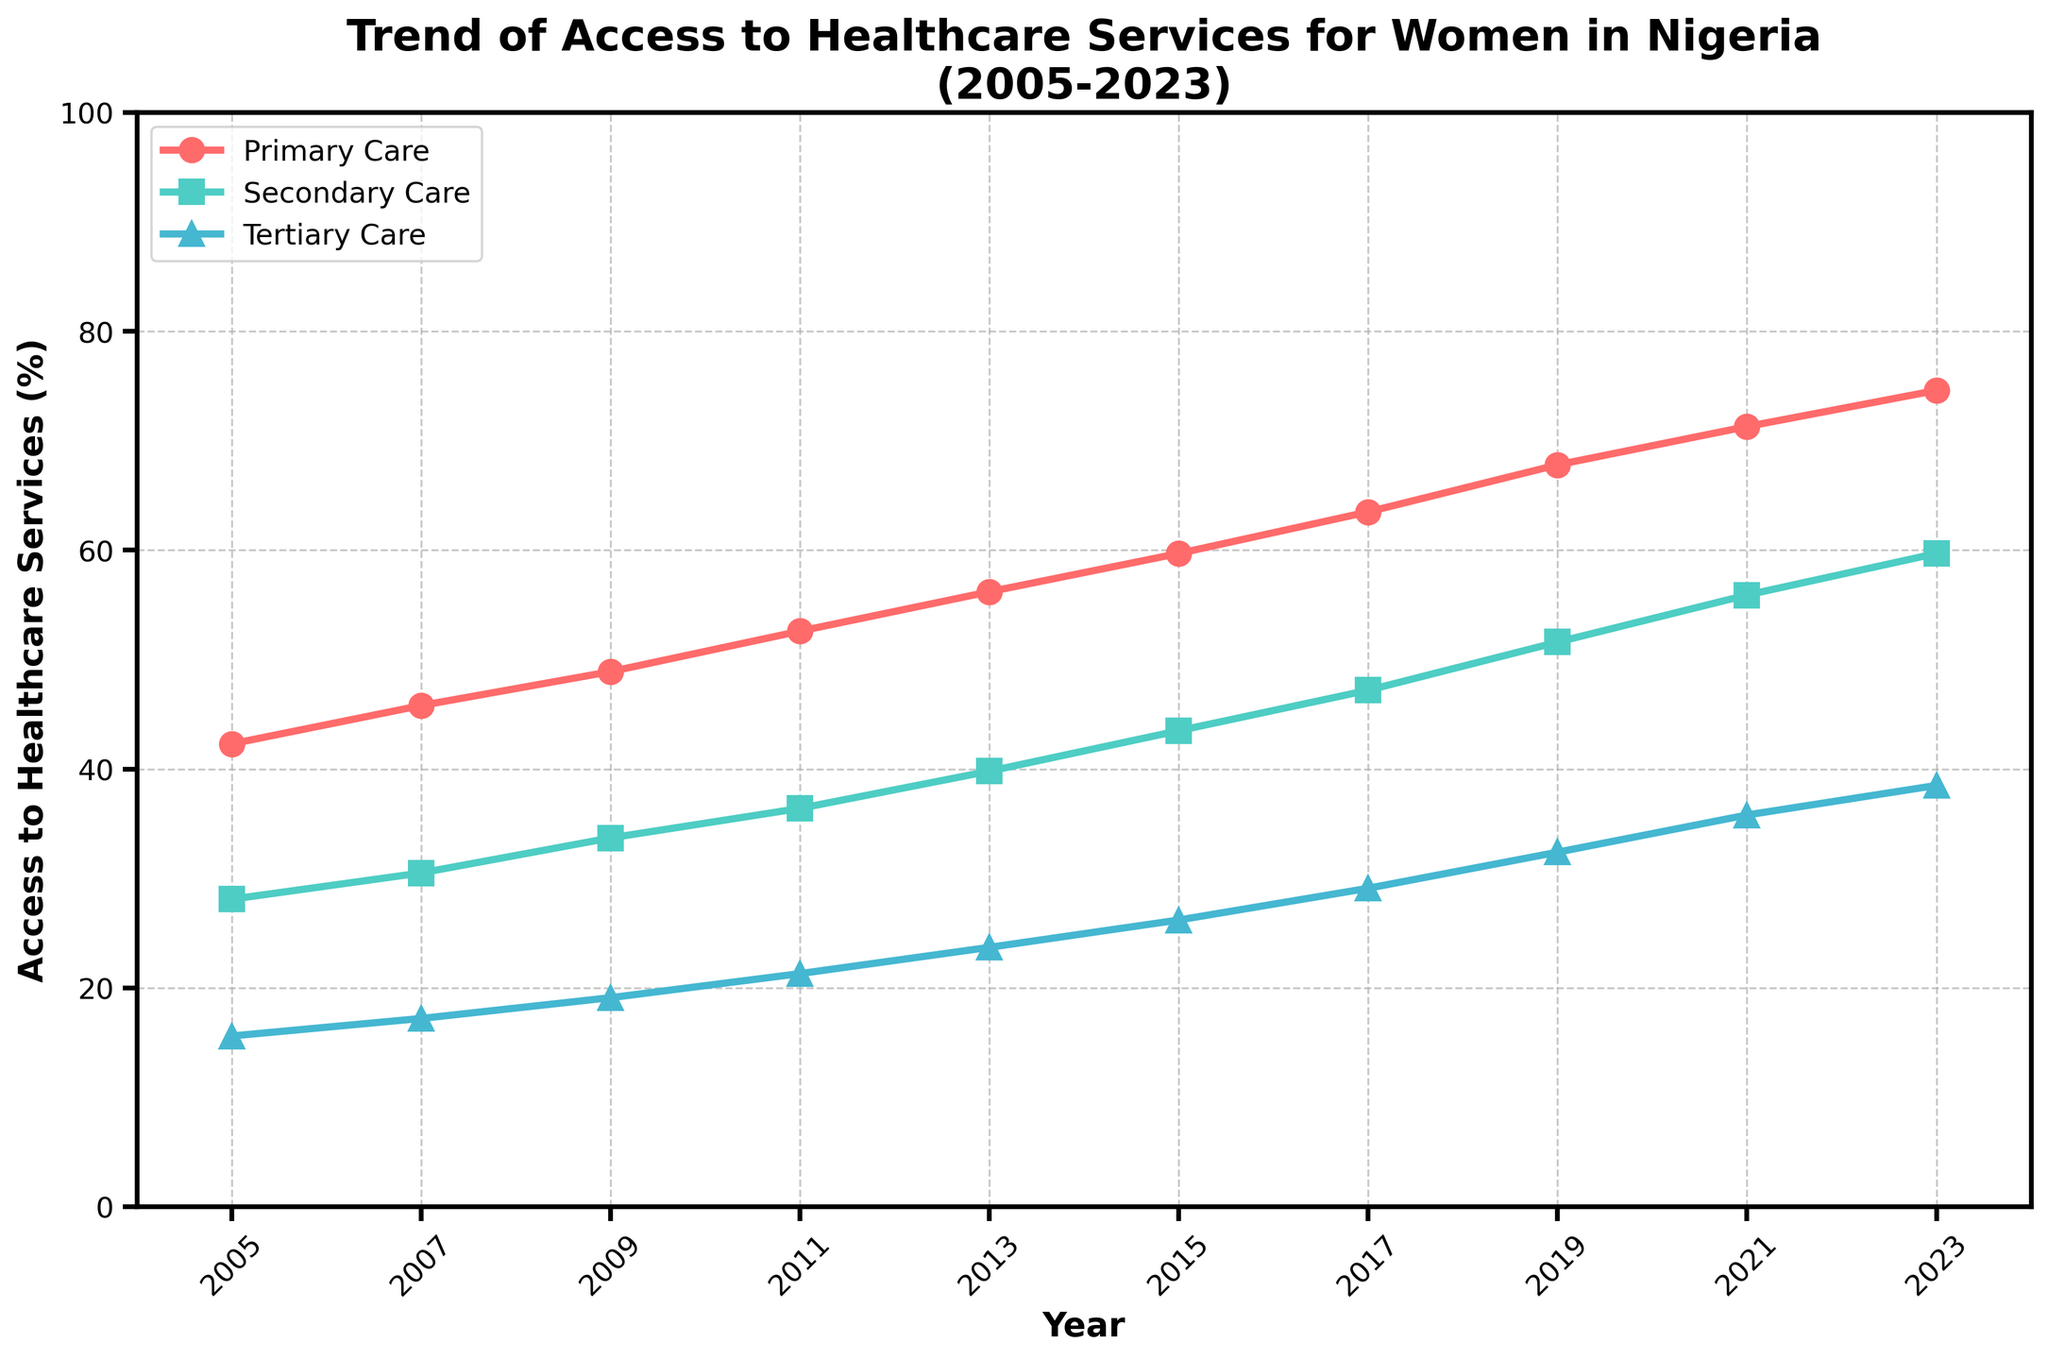What is the trend of access to primary care from 2005 to 2023? The graph shows a continuous upward trend in access to primary care from 42.3% in 2005 to 74.6% in 2023.
Answer: Continuous increase In what year did secondary care access first exceed 40%? Looking at the trend line for secondary care, it first exceeded 40% in the year 2013, reaching 39.8%.
Answer: 2013 By how much did access to tertiary care increase between 2005 and 2023? Subtracting the access percentage in 2005 (15.6%) from that in 2023 (38.5%), the increase is 38.5% - 15.6% = 22.9%.
Answer: 22.9% Which type of healthcare service saw the largest percentage increase from 2005 to 2023? By comparing the increases: Primary Care (74.6% - 42.3% = 32.3%), Secondary Care (59.7% - 28.1% = 31.6%), Tertiary Care (38.5% - 15.6% = 22.9%), Primary Care saw the largest increase.
Answer: Primary Care In 2017, what was the difference between access to primary care and tertiary care? In 2017, primary care was at 63.5% and tertiary care was at 29.1%. The difference is 63.5% - 29.1% = 34.4%.
Answer: 34.4% Which year had the steepest increase in primary care access compared to the previous year? By calculating the yearly increments, we see 2015-2017 had the steepest increase: 63.5% (2017) - 59.7% (2015) = 3.8%.
Answer: 2015-2017 Compare the trends of secondary care and tertiary care: which had a more consistent increase over the period? Both show steady increases, but secondary care increases more consistently than tertiary care, as the secondary care line is smoother.
Answer: Secondary Care In 2021, what is the ratio of access to secondary care and access to tertiary care? The access percentages in 2021 are 55.9% for secondary care and 35.8% for tertiary care. The ratio is 55.9 / 35.8 ≈ 1.56.
Answer: 1.56 What is the combined access to all three types of healthcare services in 2019? Adding up the percentages in 2019: Primary (67.8%), Secondary (51.6%), and Tertiary (32.4%) give 67.8% + 51.6% + 32.4% = 151.8%.
Answer: 151.8% 